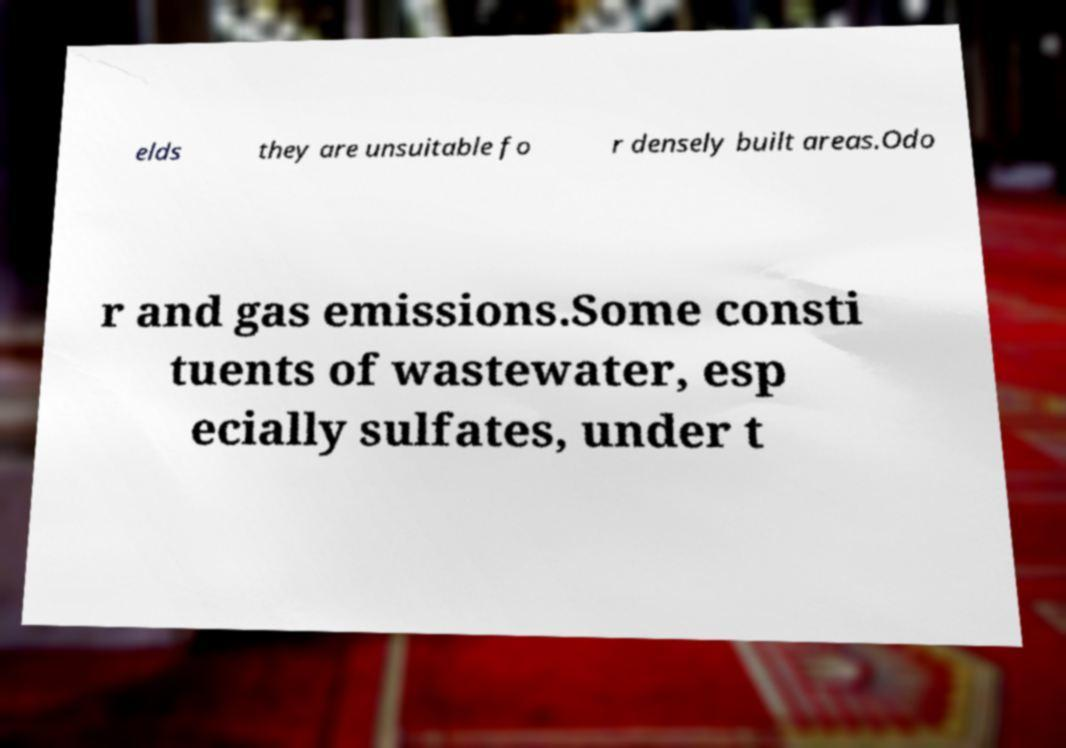There's text embedded in this image that I need extracted. Can you transcribe it verbatim? elds they are unsuitable fo r densely built areas.Odo r and gas emissions.Some consti tuents of wastewater, esp ecially sulfates, under t 